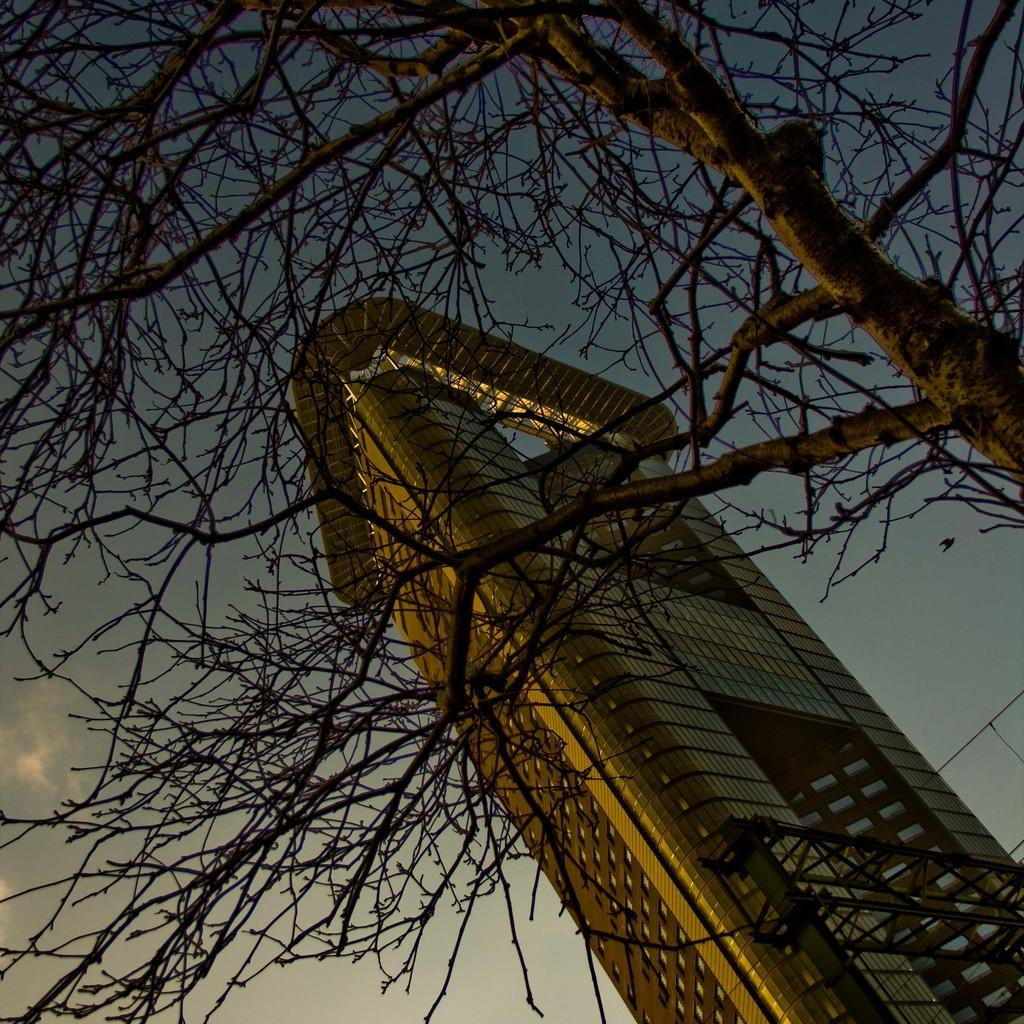What type of structure is present in the image? There is a building in the image. What other natural element can be seen in the image? There is a tree in the image. What is visible in the background of the image? The sky is visible in the background of the image. What type of lace can be seen on the building in the image? There is no lace present on the building in the image. Is there a hospital visible in the image? The image does not show a hospital; it only features a building and a tree. 